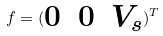Convert formula to latex. <formula><loc_0><loc_0><loc_500><loc_500>f = ( \begin{matrix} 0 & 0 & V _ { s } \end{matrix} ) ^ { T }</formula> 